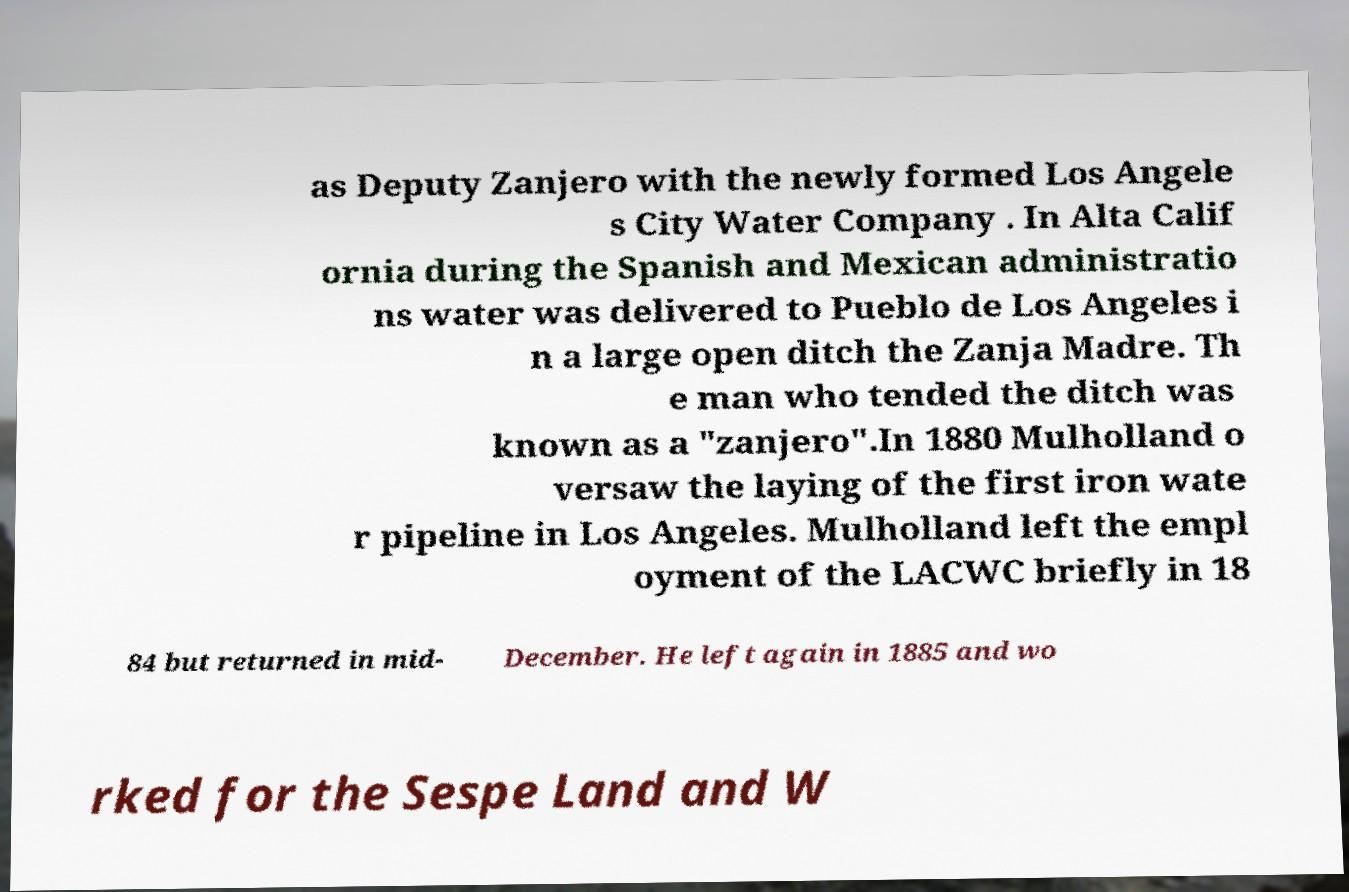Can you read and provide the text displayed in the image?This photo seems to have some interesting text. Can you extract and type it out for me? as Deputy Zanjero with the newly formed Los Angele s City Water Company . In Alta Calif ornia during the Spanish and Mexican administratio ns water was delivered to Pueblo de Los Angeles i n a large open ditch the Zanja Madre. Th e man who tended the ditch was known as a "zanjero".In 1880 Mulholland o versaw the laying of the first iron wate r pipeline in Los Angeles. Mulholland left the empl oyment of the LACWC briefly in 18 84 but returned in mid- December. He left again in 1885 and wo rked for the Sespe Land and W 